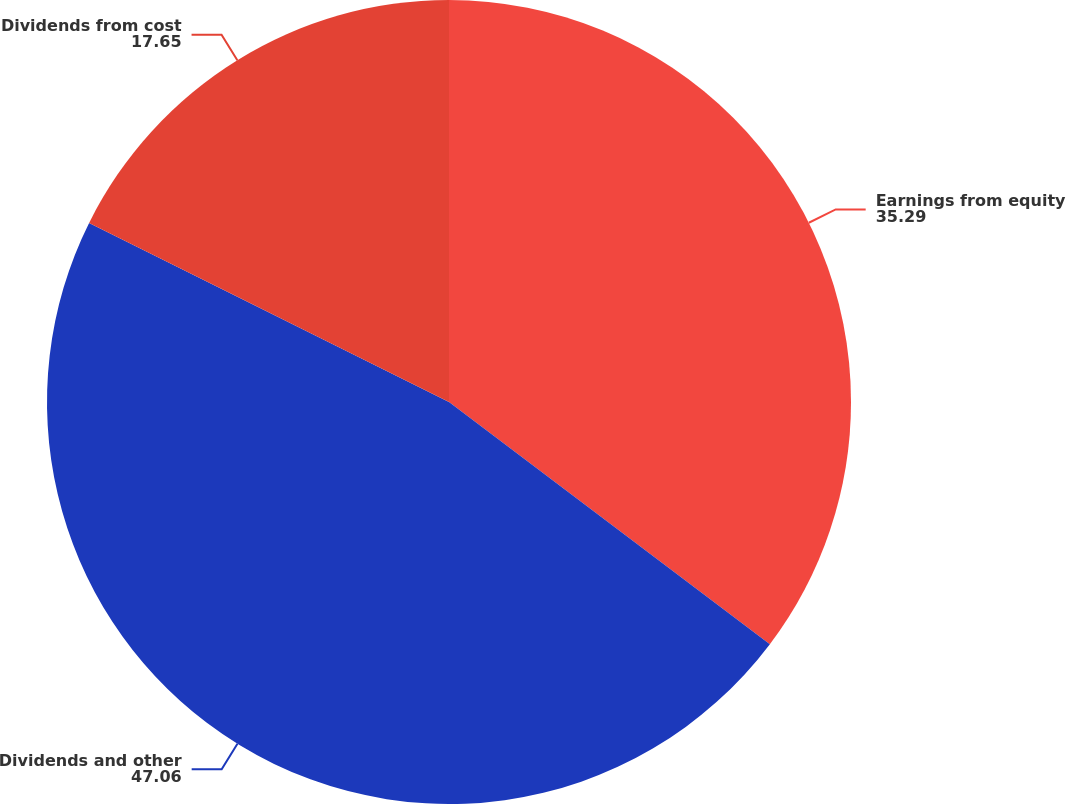Convert chart to OTSL. <chart><loc_0><loc_0><loc_500><loc_500><pie_chart><fcel>Earnings from equity<fcel>Dividends and other<fcel>Dividends from cost<nl><fcel>35.29%<fcel>47.06%<fcel>17.65%<nl></chart> 